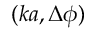Convert formula to latex. <formula><loc_0><loc_0><loc_500><loc_500>( k a , \Delta \phi )</formula> 